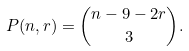<formula> <loc_0><loc_0><loc_500><loc_500>P ( n , r ) = \binom { n - 9 - 2 r } { 3 } .</formula> 